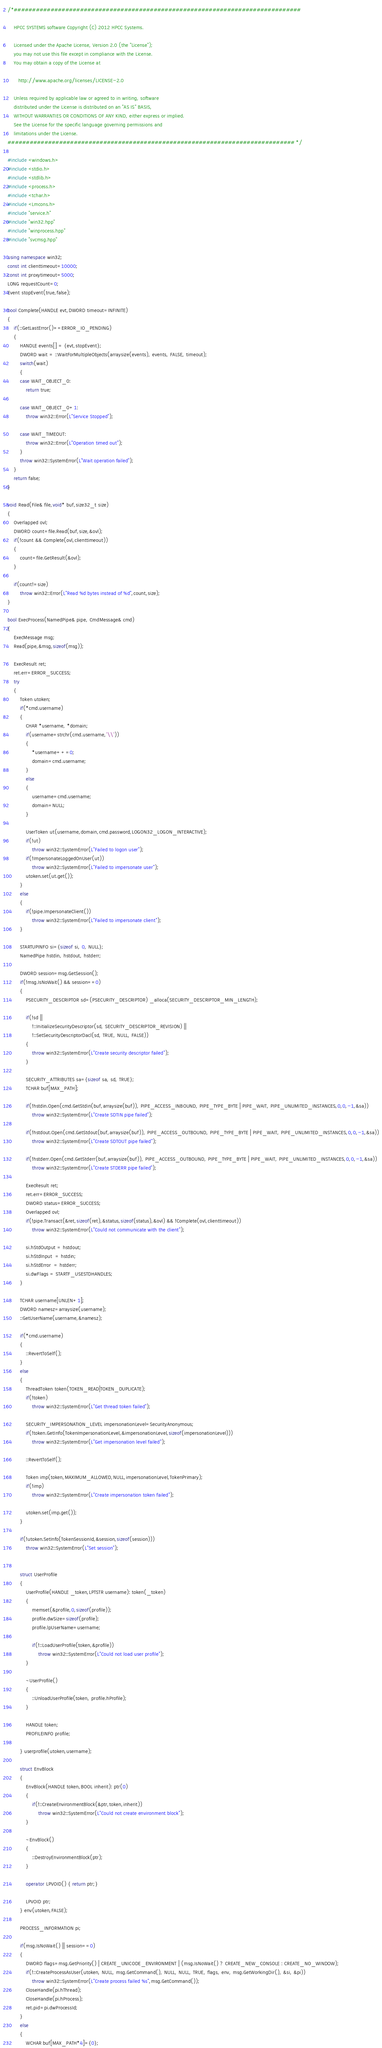Convert code to text. <code><loc_0><loc_0><loc_500><loc_500><_C++_>/*##############################################################################

    HPCC SYSTEMS software Copyright (C) 2012 HPCC Systems.

    Licensed under the Apache License, Version 2.0 (the "License");
    you may not use this file except in compliance with the License.
    You may obtain a copy of the License at

       http://www.apache.org/licenses/LICENSE-2.0

    Unless required by applicable law or agreed to in writing, software
    distributed under the License is distributed on an "AS IS" BASIS,
    WITHOUT WARRANTIES OR CONDITIONS OF ANY KIND, either express or implied.
    See the License for the specific language governing permissions and
    limitations under the License.
############################################################################## */

#include <windows.h>
#include <stdio.h>
#include <stdlib.h>
#include <process.h>
#include <tchar.h>
#include <Lmcons.h>
#include "service.h"
#include "win32.hpp"
#include "winprocess.hpp"
#include "svcmsg.hpp"

using namespace win32;
const int clienttimeout=10000;
const int proxytimeout=5000;
LONG requestCount=0;
Event stopEvent(true,false);

bool Complete(HANDLE evt,DWORD timeout=INFINITE)
{
    if(::GetLastError()==ERROR_IO_PENDING)
    {
        HANDLE events[] = {evt,stopEvent};
        DWORD wait = ::WaitForMultipleObjects(arraysize(events), events, FALSE, timeout);
        switch(wait)
        {
        case WAIT_OBJECT_0:
            return true;

        case WAIT_OBJECT_0+1:
            throw win32::Error(L"Service Stopped");

        case WAIT_TIMEOUT:
            throw win32::Error(L"Operation timed out");
        }
        throw win32::SystemError(L"Wait operation failed");
    }
    return false; 
}

void Read(File& file,void* buf,size32_t size)
{
    Overlapped ovl;
    DWORD count=file.Read(buf,size,&ovl);
    if(!count && Complete(ovl,clienttimeout))
    {
        count=file.GetResult(&ovl);
    }

    if(count!=size) 
        throw win32::Error(L"Read %d bytes instead of %d",count,size);
}

bool ExecProcess(NamedPipe& pipe, CmdMessage& cmd)
{
    ExecMessage msg;
    Read(pipe,&msg,sizeof(msg));

    ExecResult ret;
    ret.err=ERROR_SUCCESS;
    try
    {
        Token utoken;
        if(*cmd.username)
        { 
            CHAR *username, *domain;
            if(username=strchr(cmd.username,'\\'))
            {
                *username++=0;
                domain=cmd.username;
            }
            else
            {
                username=cmd.username;
                domain=NULL;
            }
             
            UserToken ut(username,domain,cmd.password,LOGON32_LOGON_INTERACTIVE);
            if(!ut)
                throw win32::SystemError(L"Failed to logon user");
            if(!ImpersonateLoggedOnUser(ut))
                throw win32::SystemError(L"Failed to impersonate user");
            utoken.set(ut.get());
        }
        else
        {
            if(!pipe.ImpersonateClient())
                throw win32::SystemError(L"Failed to impersonate client");
        }

        STARTUPINFO si={sizeof si, 0, NULL};
        NamedPipe hstdin, hstdout, hstderr;

        DWORD session=msg.GetSession();
        if(!msg.IsNoWait() && session==0)
        {
            PSECURITY_DESCRIPTOR sd=(PSECURITY_DESCRIPTOR) _alloca(SECURITY_DESCRIPTOR_MIN_LENGTH);

            if(!sd || 
                !::InitializeSecurityDescriptor(sd, SECURITY_DESCRIPTOR_REVISION) ||
                !::SetSecurityDescriptorDacl(sd, TRUE, NULL, FALSE))       
            {
                throw win32::SystemError(L"Create security descriptor failed");
            }

            SECURITY_ATTRIBUTES sa={sizeof sa, sd, TRUE};
            TCHAR buf[MAX_PATH];

            if(!hstdin.Open(cmd.GetStdin(buf,arraysize(buf)), PIPE_ACCESS_INBOUND, PIPE_TYPE_BYTE | PIPE_WAIT, PIPE_UNLIMITED_INSTANCES,0,0,-1,&sa))
                throw win32::SystemError(L"Create SDTIN pipe failed");

            if(!hstdout.Open(cmd.GetStdout(buf,arraysize(buf)), PIPE_ACCESS_OUTBOUND, PIPE_TYPE_BYTE | PIPE_WAIT, PIPE_UNLIMITED_INSTANCES,0,0,-1,&sa))
                throw win32::SystemError(L"Create SDTOUT pipe failed");

            if(!hstderr.Open(cmd.GetStderr(buf,arraysize(buf)), PIPE_ACCESS_OUTBOUND, PIPE_TYPE_BYTE | PIPE_WAIT, PIPE_UNLIMITED_INSTANCES,0,0,-1,&sa))
                throw win32::SystemError(L"Create STDERR pipe failed");

            ExecResult ret;
            ret.err=ERROR_SUCCESS;
            DWORD status=ERROR_SUCCESS;
            Overlapped ovl;
            if(!pipe.Transact(&ret,sizeof(ret),&status,sizeof(status),&ovl) && !Complete(ovl,clienttimeout))
                throw win32::SystemError(L"Could not communicate with the client");

            si.hStdOutput = hstdout;
            si.hStdInput  = hstdin;
            si.hStdError  = hstderr;
            si.dwFlags = STARTF_USESTDHANDLES;
        }

        TCHAR username[UNLEN+1];
        DWORD namesz=arraysize(username);
        ::GetUserName(username,&namesz);

        if(*cmd.username)
        { 
            ::RevertToSelf();
        }
        else
        {
            ThreadToken token(TOKEN_READ|TOKEN_DUPLICATE);
            if(!token)
                throw win32::SystemError(L"Get thread token failed");

            SECURITY_IMPERSONATION_LEVEL impersonationLevel=SecurityAnonymous;
            if(!token.GetInfo(TokenImpersonationLevel,&impersonationLevel,sizeof(impersonationLevel)))
                throw win32::SystemError(L"Get impersonation level failed");

            ::RevertToSelf();

            Token imp(token,MAXIMUM_ALLOWED,NULL,impersonationLevel,TokenPrimary);
            if(!imp)
                throw win32::SystemError(L"Create impersonation token failed");
    
            utoken.set(imp.get());
        }

        if(!utoken.SetInfo(TokenSessionId,&session,sizeof(session)))
            throw win32::SystemError(L"Set session");
        

        struct UserProfile
        {
            UserProfile(HANDLE _token,LPTSTR username): token(_token)
            {
                memset(&profile,0,sizeof(profile));
                profile.dwSize=sizeof(profile);
                profile.lpUserName=username; 

                if(!::LoadUserProfile(token,&profile))
                    throw win32::SystemError(L"Could not load user profile");
            }
        
            ~UserProfile()
            {
                ::UnloadUserProfile(token, profile.hProfile); 
            }

            HANDLE token;
            PROFILEINFO profile;

        } userprofile(utoken,username);

        struct EnvBlock
        {
            EnvBlock(HANDLE token,BOOL inherit): ptr(0)
            {
                if(!::CreateEnvironmentBlock(&ptr,token,inherit))
                    throw win32::SystemError(L"Could not create environment block");
            }

            ~EnvBlock()
            {
                ::DestroyEnvironmentBlock(ptr);
            }

            operator LPVOID() { return ptr;}

            LPVOID ptr;
        } env(utoken,FALSE);

        PROCESS_INFORMATION pi;

        if(msg.IsNoWait() || session==0)
        {
            DWORD flags=msg.GetPriority() | CREATE_UNICODE_ENVIRONMENT | (msg.IsNoWait() ? CREATE_NEW_CONSOLE : CREATE_NO_WINDOW);
            if(!::CreateProcessAsUser(utoken, NULL, msg.GetCommand(), NULL, NULL, TRUE, flags, env, msg.GetWorkingDir(), &si, &pi))
                throw win32::SystemError(L"Create process failed %s",msg.GetCommand());
            CloseHandle(pi.hThread);
            CloseHandle(pi.hProcess);
            ret.pid=pi.dwProcessId;
        }
        else
        {
            WCHAR buf[MAX_PATH*4]={0};</code> 